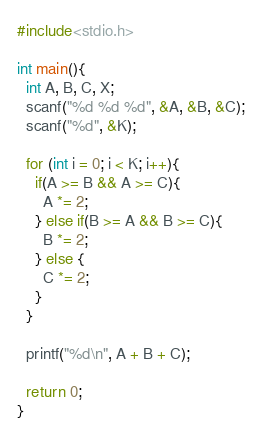<code> <loc_0><loc_0><loc_500><loc_500><_C_>#include<stdio.h>

int main(){
  int A, B, C, X;
  scanf("%d %d %d", &A, &B, &C);
  scanf("%d", &K);
  
  for (int i = 0; i < K; i++){
    if(A >= B && A >= C){
      A *= 2;
    } else if(B >= A && B >= C){
      B *= 2;
    } else {
      C *= 2;
    }
  }
  
  printf("%d\n", A + B + C);
  
  return 0;
}</code> 